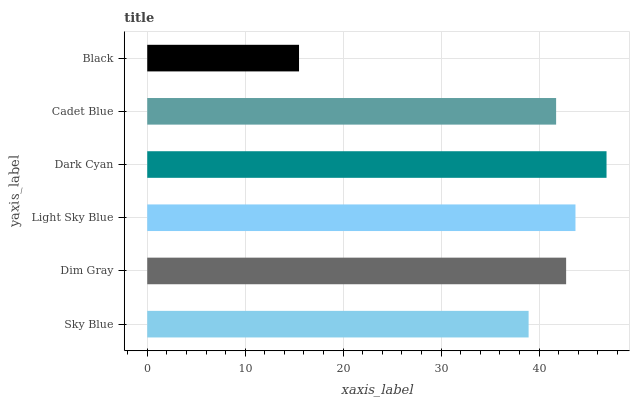Is Black the minimum?
Answer yes or no. Yes. Is Dark Cyan the maximum?
Answer yes or no. Yes. Is Dim Gray the minimum?
Answer yes or no. No. Is Dim Gray the maximum?
Answer yes or no. No. Is Dim Gray greater than Sky Blue?
Answer yes or no. Yes. Is Sky Blue less than Dim Gray?
Answer yes or no. Yes. Is Sky Blue greater than Dim Gray?
Answer yes or no. No. Is Dim Gray less than Sky Blue?
Answer yes or no. No. Is Dim Gray the high median?
Answer yes or no. Yes. Is Cadet Blue the low median?
Answer yes or no. Yes. Is Dark Cyan the high median?
Answer yes or no. No. Is Light Sky Blue the low median?
Answer yes or no. No. 